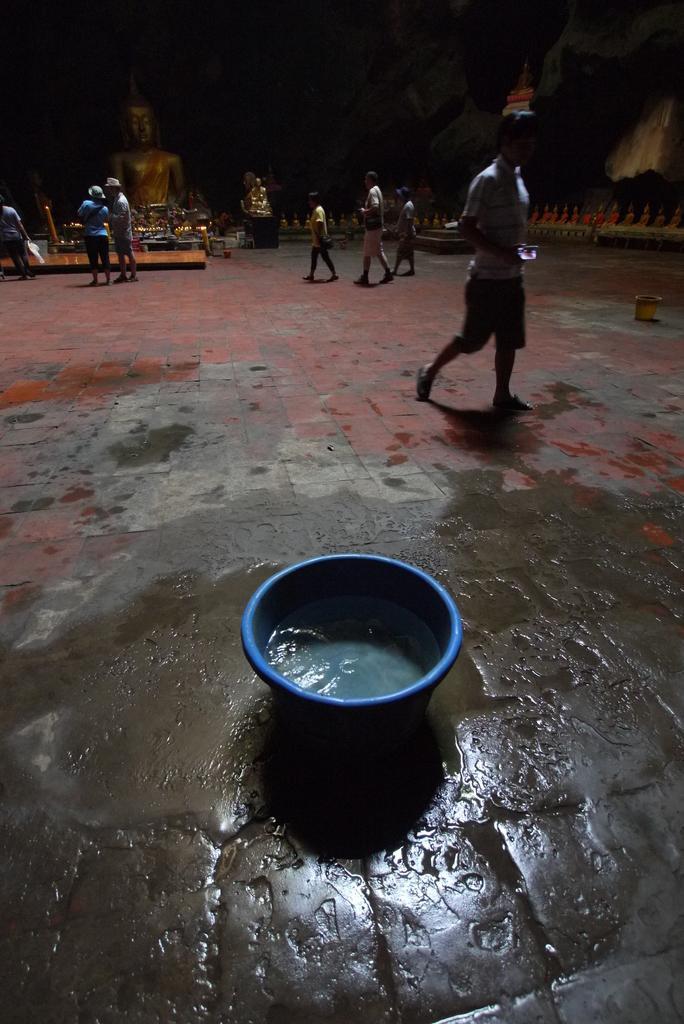Can you describe this image briefly? In this image we can see water in the tub, behind the tub there are few people walking in front of the statue. The background is dark. 